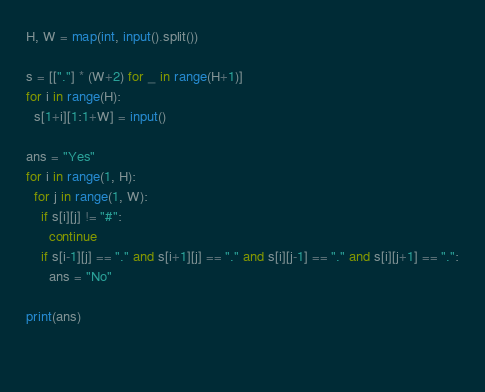<code> <loc_0><loc_0><loc_500><loc_500><_Python_>H, W = map(int, input().split())

s = [["."] * (W+2) for _ in range(H+1)]
for i in range(H):
  s[1+i][1:1+W] = input()

ans = "Yes"
for i in range(1, H):
  for j in range(1, W):
    if s[i][j] != "#":
      continue
    if s[i-1][j] == "." and s[i+1][j] == "." and s[i][j-1] == "." and s[i][j+1] == ".":
      ans = "No"
  
print(ans)
  
  </code> 